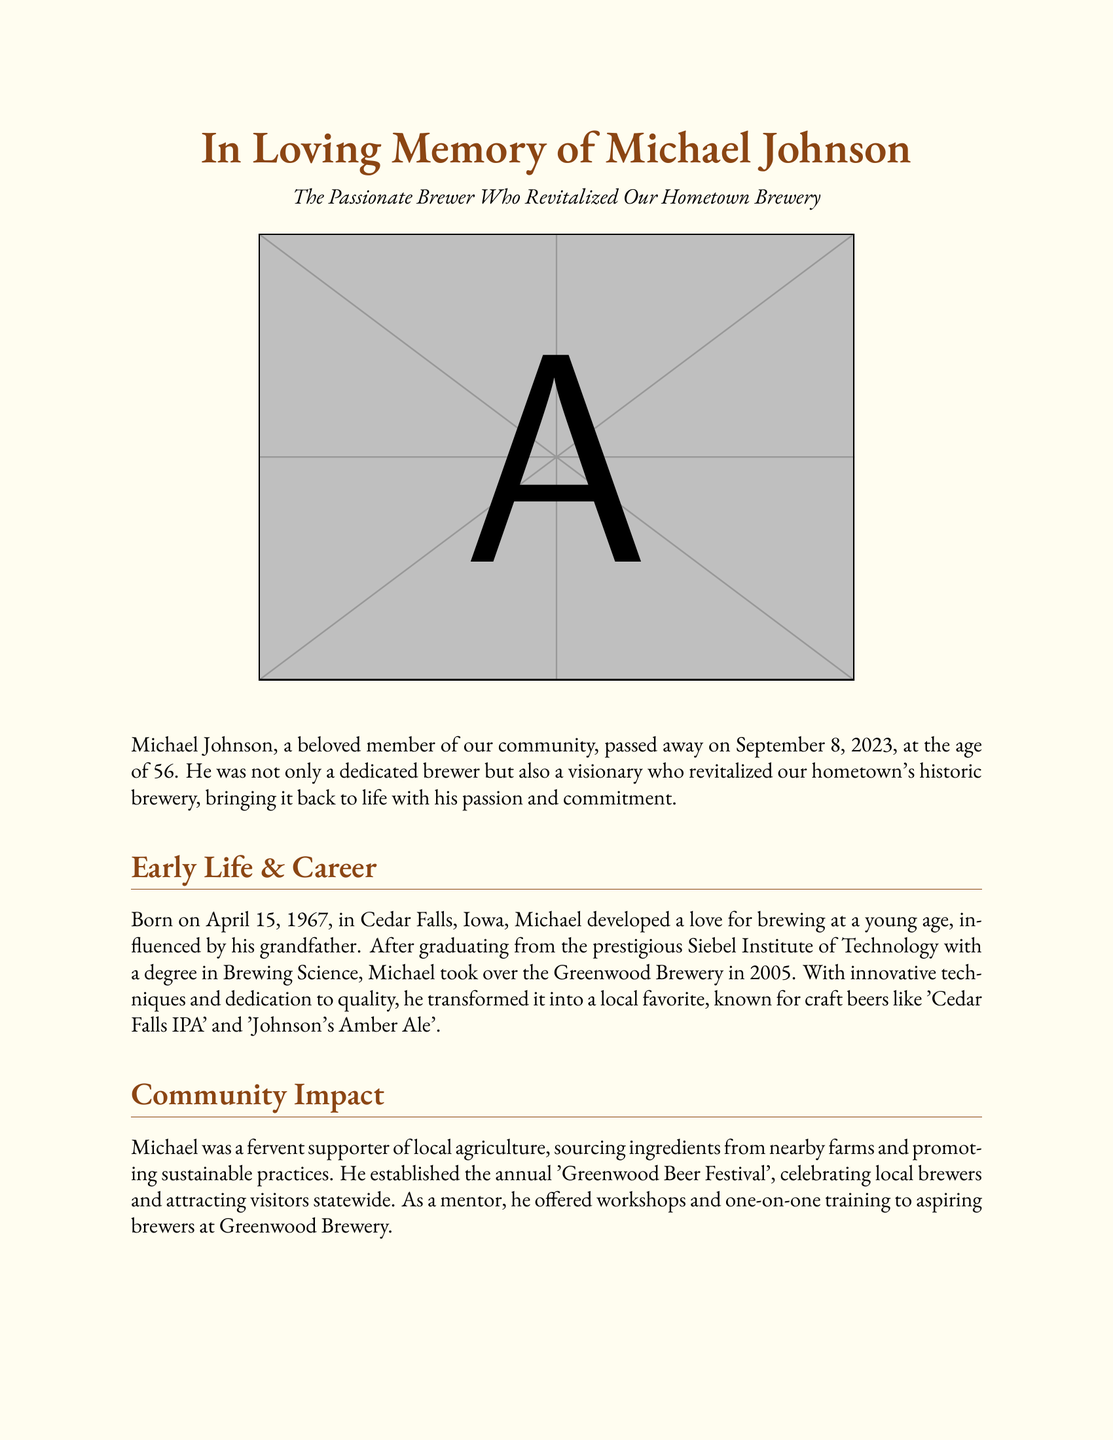What was Michael Johnson's age at death? Michael Johnson passed away at the age of 56, as stated in the document.
Answer: 56 When was Michael Johnson born? The document states that Michael was born on April 15, 1967.
Answer: April 15, 1967 What did Michael Johnson's grandfather influence him to love? Michael developed a love for brewing, influenced by his grandfather.
Answer: Brewing What is the name of the beer festival Michael established? The document mentions the annual 'Greenwood Beer Festival' which Michael established.
Answer: Greenwood Beer Festival How many children did Michael Johnson have? It is mentioned in the document that Michael is survived by two children.
Answer: Two What was the name of the brewery Michael took over? The document states that he took over the Greenwood Brewery in 2005.
Answer: Greenwood Brewery What did Michael Johnson enjoy besides brewing? The document lists fishing, woodworking, and volunteering as additional interests.
Answer: Fishing What quote reflects Michael Johnson's philosophy on life? The document contains a quote that emphasizes passion and quality in brewing.
Answer: "Life is too short to drink bad beer." 